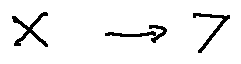<formula> <loc_0><loc_0><loc_500><loc_500>X \rightarrow Y</formula> 